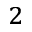Convert formula to latex. <formula><loc_0><loc_0><loc_500><loc_500>^ { 2 }</formula> 